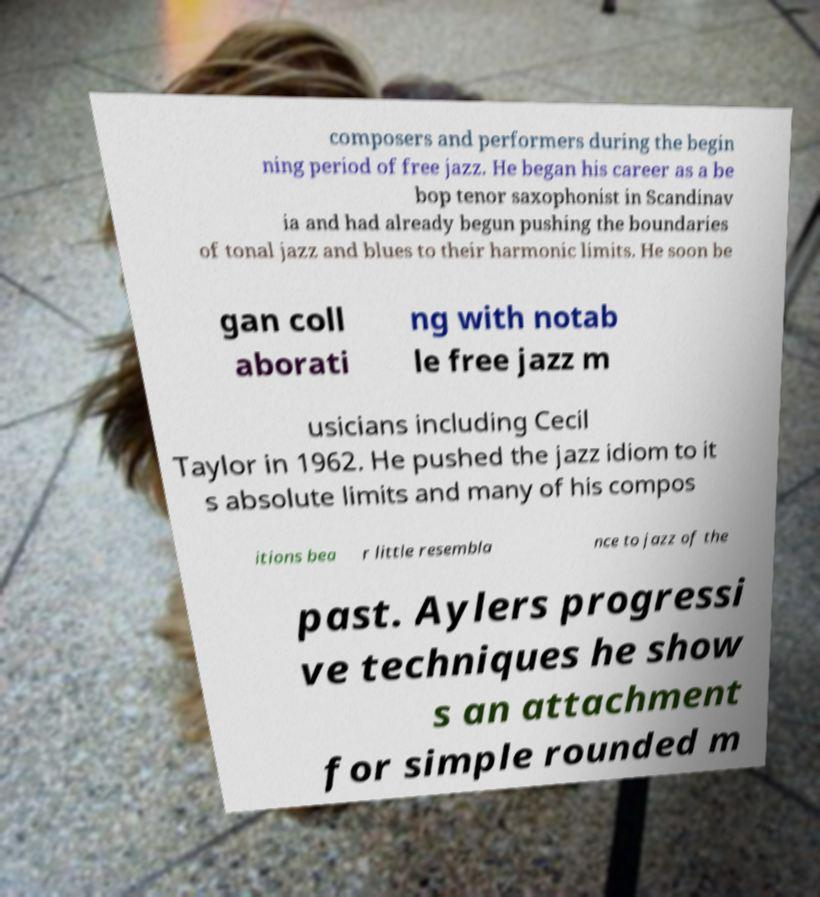What messages or text are displayed in this image? I need them in a readable, typed format. composers and performers during the begin ning period of free jazz. He began his career as a be bop tenor saxophonist in Scandinav ia and had already begun pushing the boundaries of tonal jazz and blues to their harmonic limits. He soon be gan coll aborati ng with notab le free jazz m usicians including Cecil Taylor in 1962. He pushed the jazz idiom to it s absolute limits and many of his compos itions bea r little resembla nce to jazz of the past. Aylers progressi ve techniques he show s an attachment for simple rounded m 